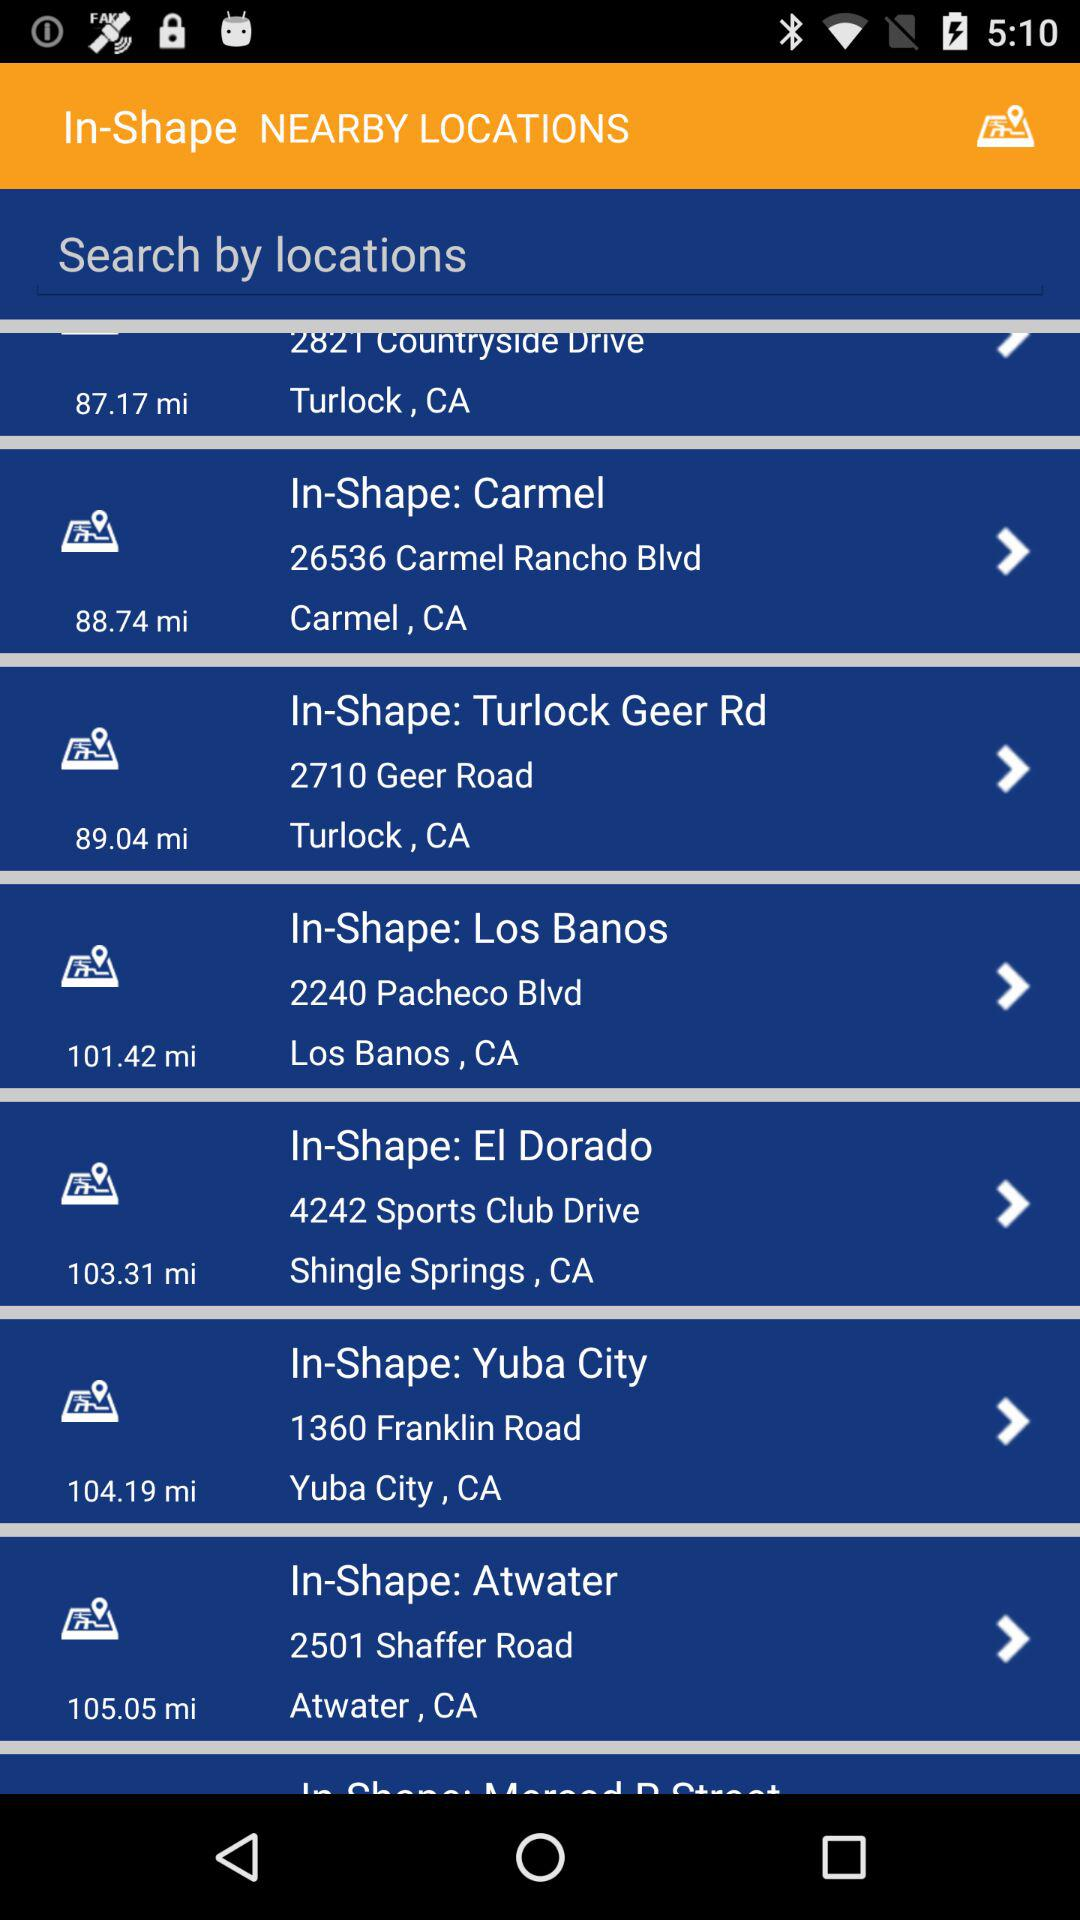How far is Yuba City? Yuba City is 104.19 miles away. 